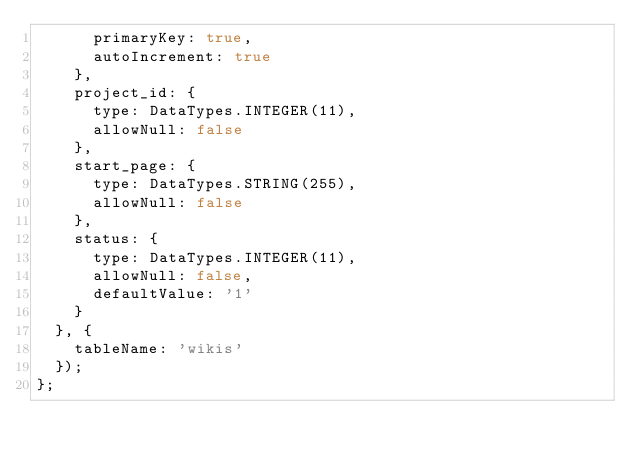Convert code to text. <code><loc_0><loc_0><loc_500><loc_500><_JavaScript_>      primaryKey: true,
      autoIncrement: true
    },
    project_id: {
      type: DataTypes.INTEGER(11),
      allowNull: false
    },
    start_page: {
      type: DataTypes.STRING(255),
      allowNull: false
    },
    status: {
      type: DataTypes.INTEGER(11),
      allowNull: false,
      defaultValue: '1'
    }
  }, {
    tableName: 'wikis'
  });
};
</code> 